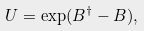Convert formula to latex. <formula><loc_0><loc_0><loc_500><loc_500>U = \exp ( { B ^ { \dagger } } - B ) ,</formula> 